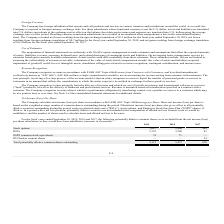According to Mitek Systems's financial document, How does the company calculate net income (loss) per share? Based on the financial document, the answer is in accordance with FASB ASC Topic 260,Earnings per Share. Also, What is basic net income (loss) per share based on? the weighted-average number of common shares outstanding during the period. The document states: "based on the weighted-average number of common shares outstanding during the period. Diluted net income (loss) per share also gives effect to all pote..." Also, What is the amount of potentially dilutive common shares outstanding of stock options and RSUs in 2019, respectively? The document shows two values: 1,687 and 2,352 (in thousands). From the document: "RSUs 2,352 2,580 83 Stock options 1,687 2,806 569..." Also, can you calculate: What is the percentage change in the amount of potentially dilutive common shares outstanding of ESPP common stock equivalents from 2018 to 2019? To answer this question, I need to perform calculations using the financial data. The calculation is: (74-71)/71 , which equals 4.23 (percentage). This is based on the information: "ESPP common stock equivalents 74 71 — ESPP common stock equivalents 74 71 —..." The key data points involved are: 71, 74. Also, can you calculate: What is the average of total potentially dilutive common shares outstanding from 2017 to 2019? To answer this question, I need to perform calculations using the financial data. The calculation is: (4,113+5,457+676)/3 , which equals 3415.33 (in thousands). This is based on the information: "entially dilutive common shares outstanding 4,113 5,457 676 ly dilutive common shares outstanding 4,113 5,457 676 al potentially dilutive common shares outstanding 4,113 5,457 676..." The key data points involved are: 4,113, 5,457, 676. Also, can you calculate: What is the ratio of the amount of stock options between 2018 to 2019? Based on the calculation: 2,806/1,687 , the result is 1.66. This is based on the information: "Stock options 1,687 2,806 569 Stock options 1,687 2,806 569..." The key data points involved are: 1,687, 2,806. 